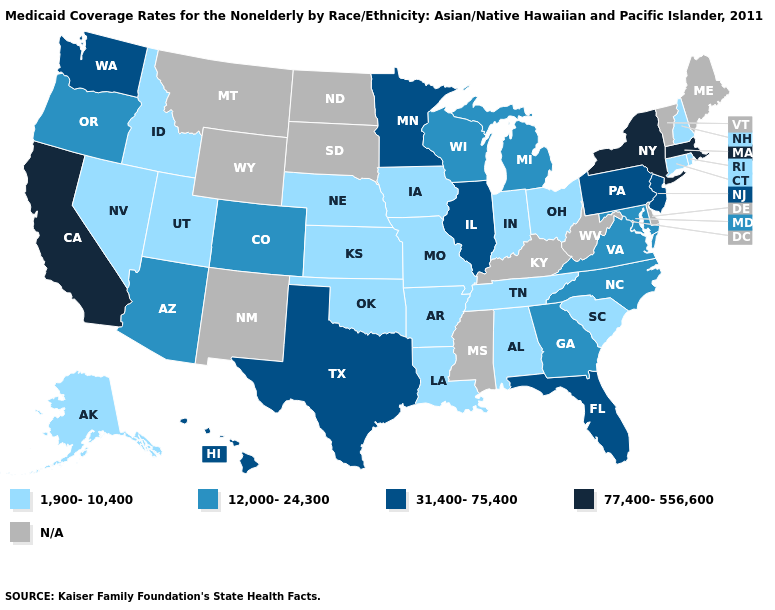Which states have the lowest value in the USA?
Quick response, please. Alabama, Alaska, Arkansas, Connecticut, Idaho, Indiana, Iowa, Kansas, Louisiana, Missouri, Nebraska, Nevada, New Hampshire, Ohio, Oklahoma, Rhode Island, South Carolina, Tennessee, Utah. Is the legend a continuous bar?
Be succinct. No. What is the lowest value in states that border Nevada?
Keep it brief. 1,900-10,400. Name the states that have a value in the range 31,400-75,400?
Quick response, please. Florida, Hawaii, Illinois, Minnesota, New Jersey, Pennsylvania, Texas, Washington. How many symbols are there in the legend?
Concise answer only. 5. Name the states that have a value in the range N/A?
Quick response, please. Delaware, Kentucky, Maine, Mississippi, Montana, New Mexico, North Dakota, South Dakota, Vermont, West Virginia, Wyoming. What is the lowest value in the USA?
Answer briefly. 1,900-10,400. What is the value of Oregon?
Be succinct. 12,000-24,300. What is the highest value in states that border North Carolina?
Keep it brief. 12,000-24,300. Among the states that border Florida , does Alabama have the highest value?
Keep it brief. No. Does the first symbol in the legend represent the smallest category?
Answer briefly. Yes. Which states have the lowest value in the USA?
Quick response, please. Alabama, Alaska, Arkansas, Connecticut, Idaho, Indiana, Iowa, Kansas, Louisiana, Missouri, Nebraska, Nevada, New Hampshire, Ohio, Oklahoma, Rhode Island, South Carolina, Tennessee, Utah. Does Maryland have the lowest value in the South?
Write a very short answer. No. What is the value of Tennessee?
Be succinct. 1,900-10,400. 